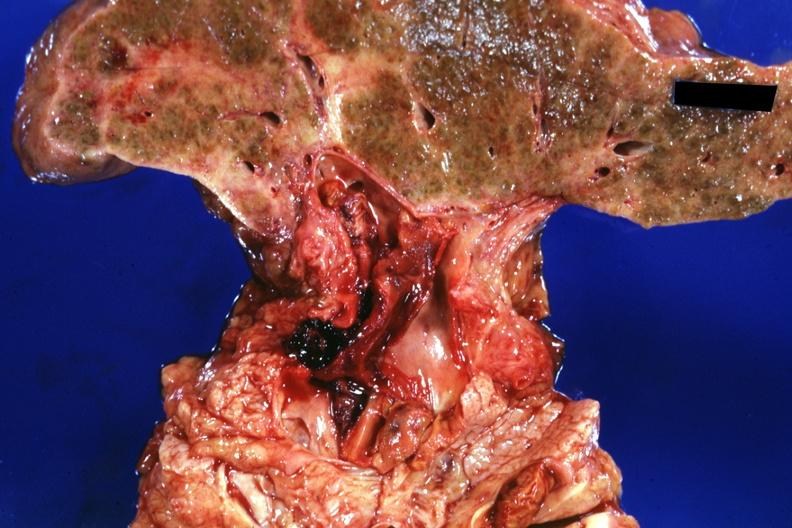what is present?
Answer the question using a single word or phrase. Hepatobiliary 